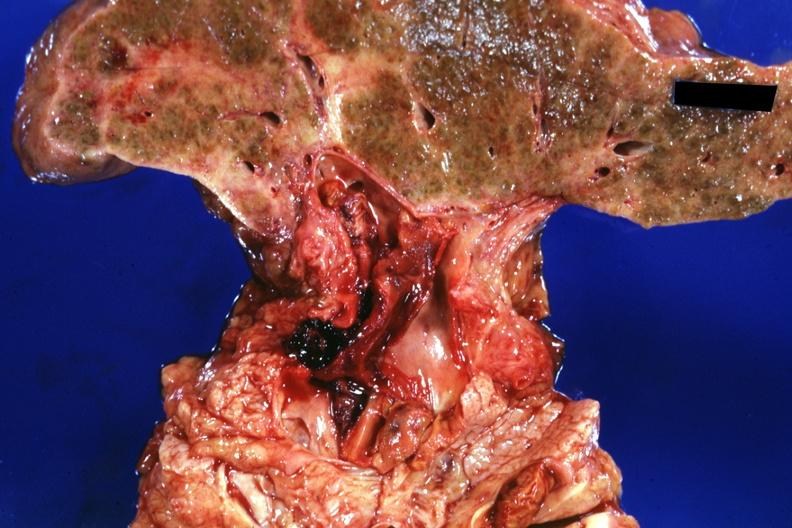what is present?
Answer the question using a single word or phrase. Hepatobiliary 